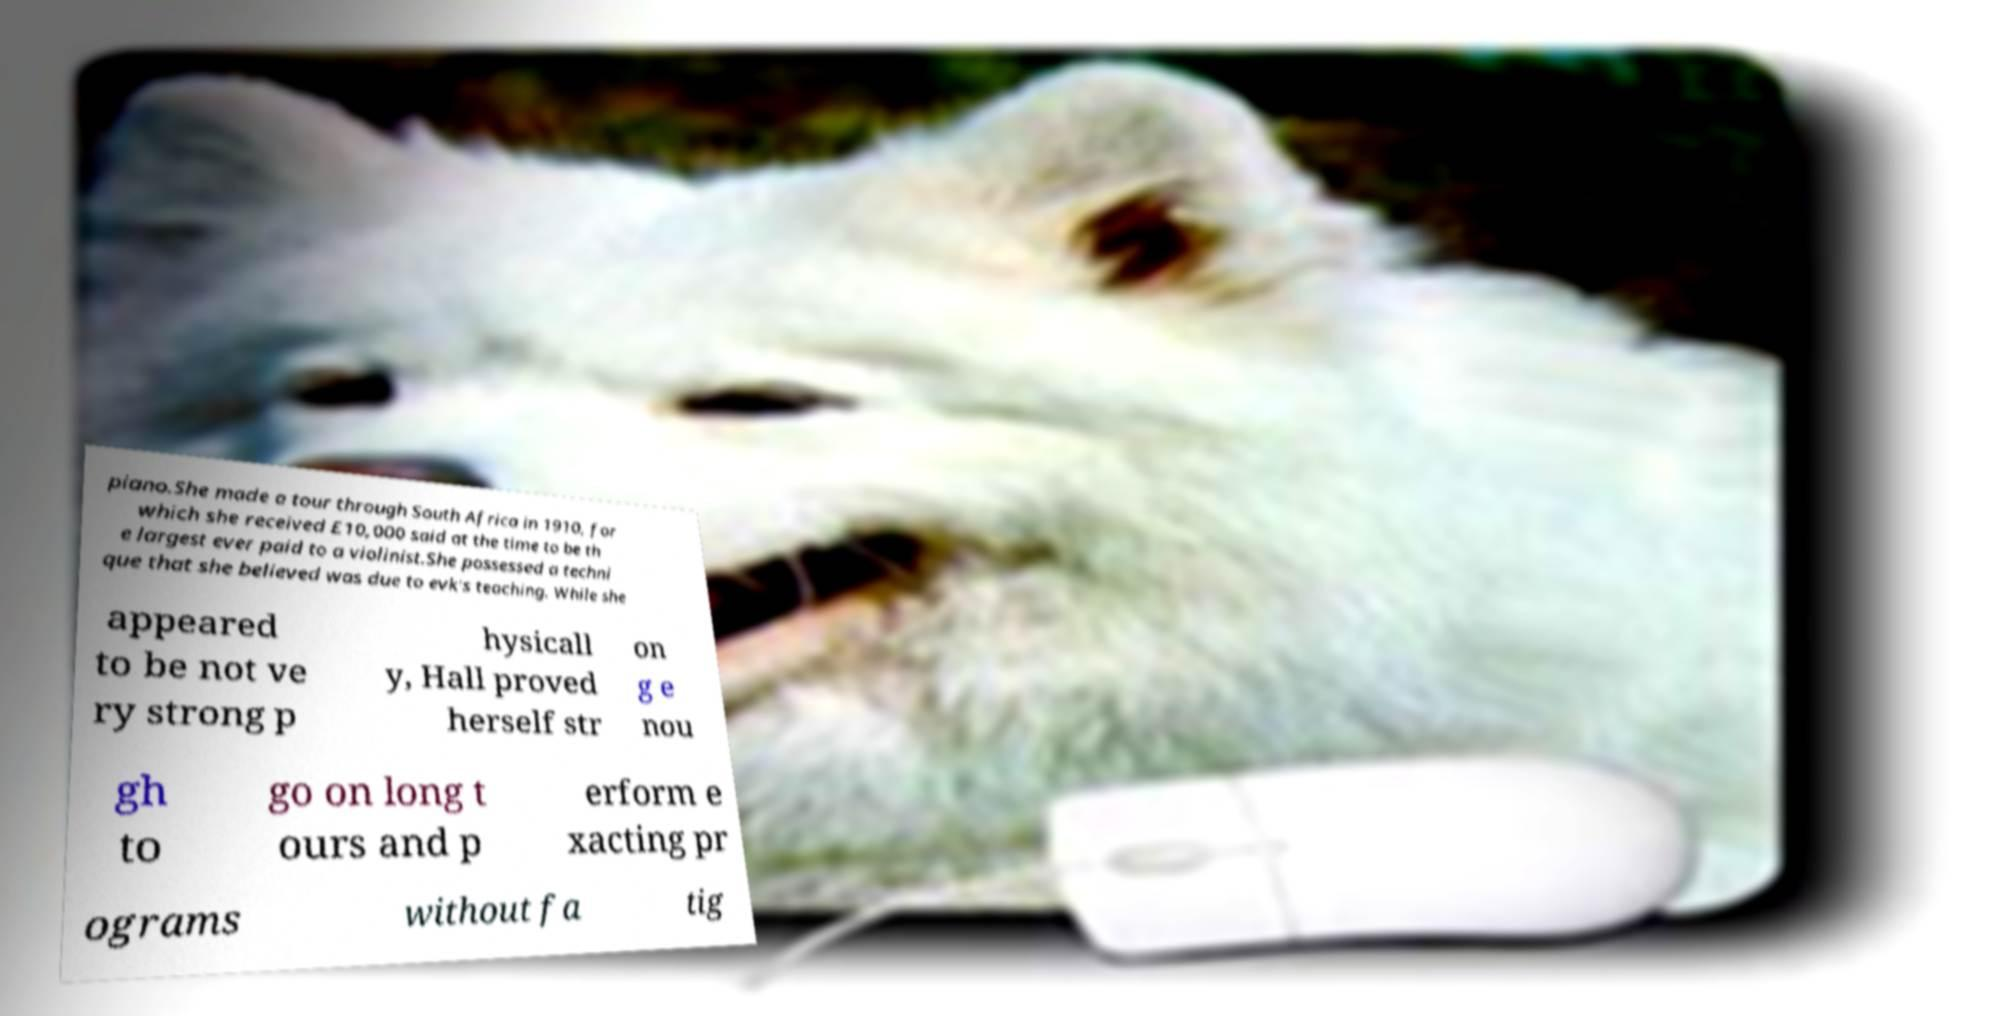Could you extract and type out the text from this image? piano.She made a tour through South Africa in 1910, for which she received £10,000 said at the time to be th e largest ever paid to a violinist.She possessed a techni que that she believed was due to evk's teaching. While she appeared to be not ve ry strong p hysicall y, Hall proved herself str on g e nou gh to go on long t ours and p erform e xacting pr ograms without fa tig 